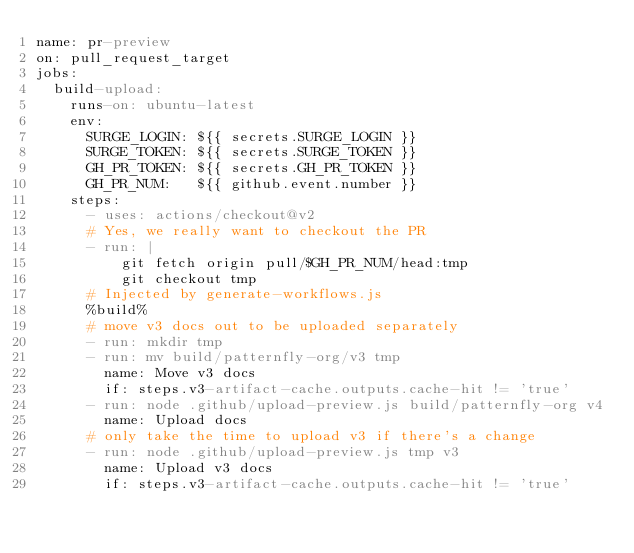<code> <loc_0><loc_0><loc_500><loc_500><_YAML_>name: pr-preview
on: pull_request_target
jobs:
  build-upload:
    runs-on: ubuntu-latest
    env:
      SURGE_LOGIN: ${{ secrets.SURGE_LOGIN }}
      SURGE_TOKEN: ${{ secrets.SURGE_TOKEN }}
      GH_PR_TOKEN: ${{ secrets.GH_PR_TOKEN }}
      GH_PR_NUM:   ${{ github.event.number }}
    steps:
      - uses: actions/checkout@v2
      # Yes, we really want to checkout the PR
      - run: |
          git fetch origin pull/$GH_PR_NUM/head:tmp
          git checkout tmp
      # Injected by generate-workflows.js
      %build%
      # move v3 docs out to be uploaded separately
      - run: mkdir tmp
      - run: mv build/patternfly-org/v3 tmp
        name: Move v3 docs
        if: steps.v3-artifact-cache.outputs.cache-hit != 'true'
      - run: node .github/upload-preview.js build/patternfly-org v4
        name: Upload docs
      # only take the time to upload v3 if there's a change
      - run: node .github/upload-preview.js tmp v3
        name: Upload v3 docs
        if: steps.v3-artifact-cache.outputs.cache-hit != 'true'

</code> 